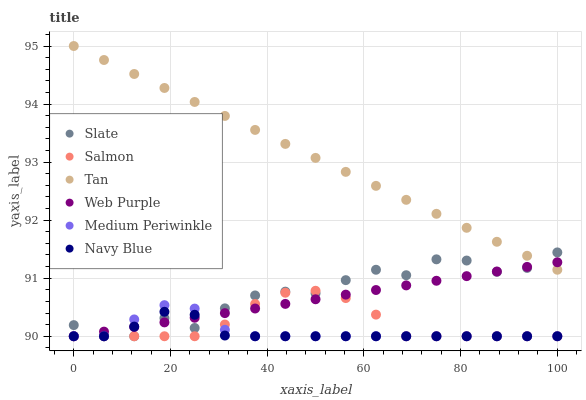Does Navy Blue have the minimum area under the curve?
Answer yes or no. Yes. Does Tan have the maximum area under the curve?
Answer yes or no. Yes. Does Slate have the minimum area under the curve?
Answer yes or no. No. Does Slate have the maximum area under the curve?
Answer yes or no. No. Is Web Purple the smoothest?
Answer yes or no. Yes. Is Slate the roughest?
Answer yes or no. Yes. Is Navy Blue the smoothest?
Answer yes or no. No. Is Navy Blue the roughest?
Answer yes or no. No. Does Medium Periwinkle have the lowest value?
Answer yes or no. Yes. Does Tan have the lowest value?
Answer yes or no. No. Does Tan have the highest value?
Answer yes or no. Yes. Does Slate have the highest value?
Answer yes or no. No. Is Salmon less than Tan?
Answer yes or no. Yes. Is Tan greater than Salmon?
Answer yes or no. Yes. Does Medium Periwinkle intersect Navy Blue?
Answer yes or no. Yes. Is Medium Periwinkle less than Navy Blue?
Answer yes or no. No. Is Medium Periwinkle greater than Navy Blue?
Answer yes or no. No. Does Salmon intersect Tan?
Answer yes or no. No. 